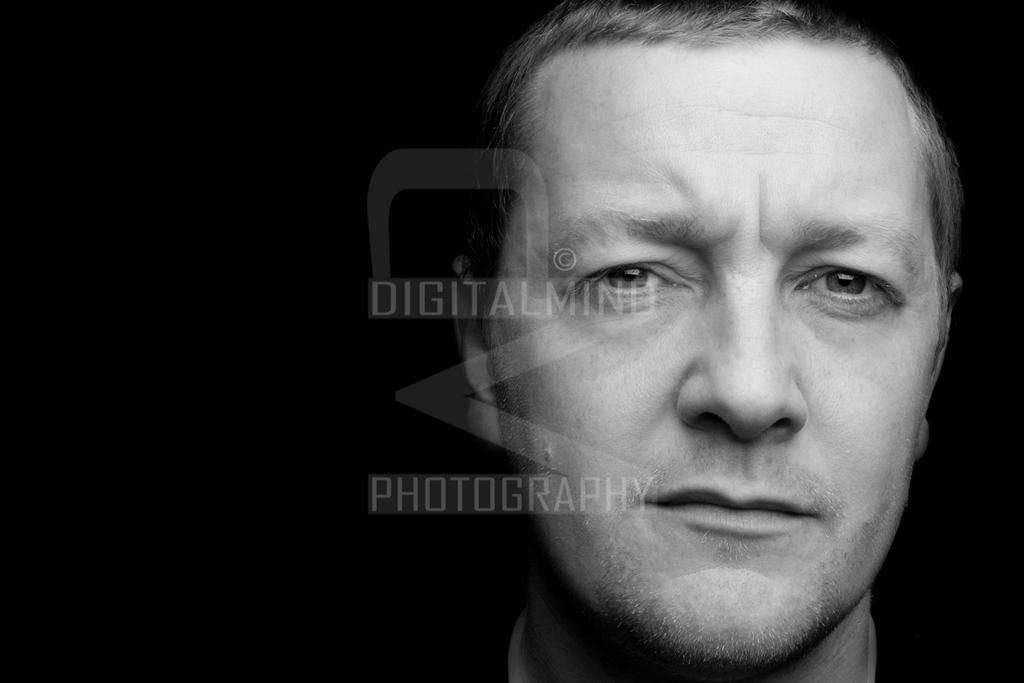What is the main subject of the image? There is a face of a man in the image. Are there any additional features in the image? Yes, there is a watermark in the image. What color scheme is used in the image? The image is black and white in color. How does the man in the image maintain a quiet atmosphere? The image does not provide any information about the man's actions or the atmosphere, so it cannot be determined if he is maintaining a quiet atmosphere. 